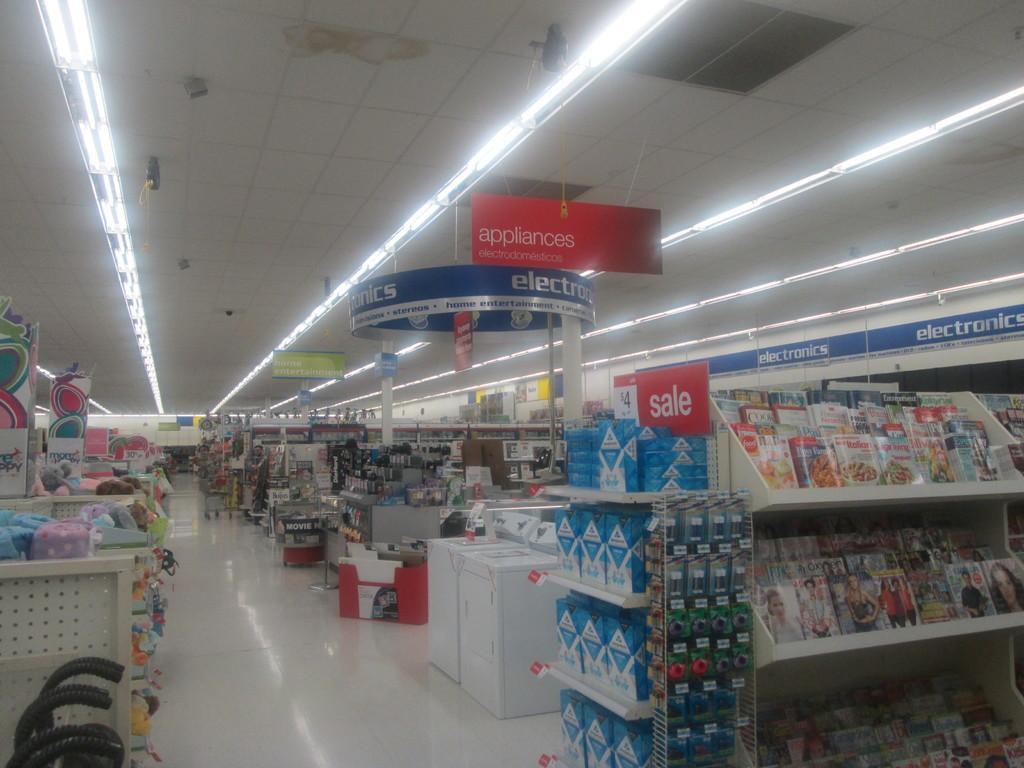<image>
Relay a brief, clear account of the picture shown. A wide isle in a department store that sells appliances. 